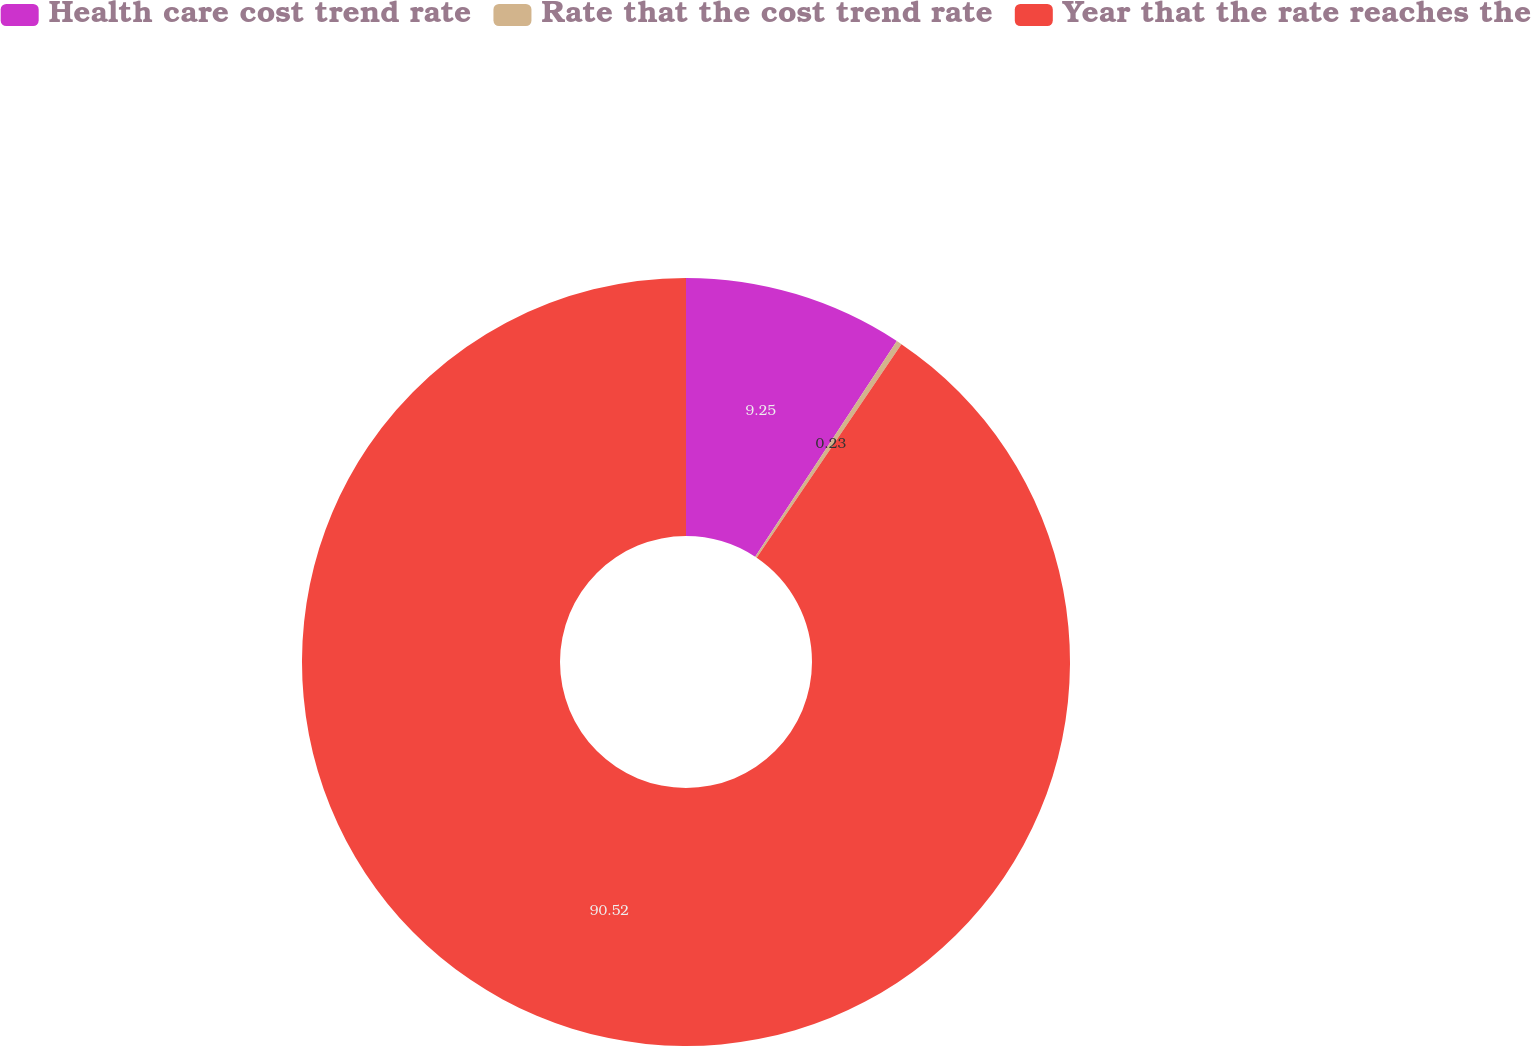Convert chart. <chart><loc_0><loc_0><loc_500><loc_500><pie_chart><fcel>Health care cost trend rate<fcel>Rate that the cost trend rate<fcel>Year that the rate reaches the<nl><fcel>9.25%<fcel>0.23%<fcel>90.52%<nl></chart> 